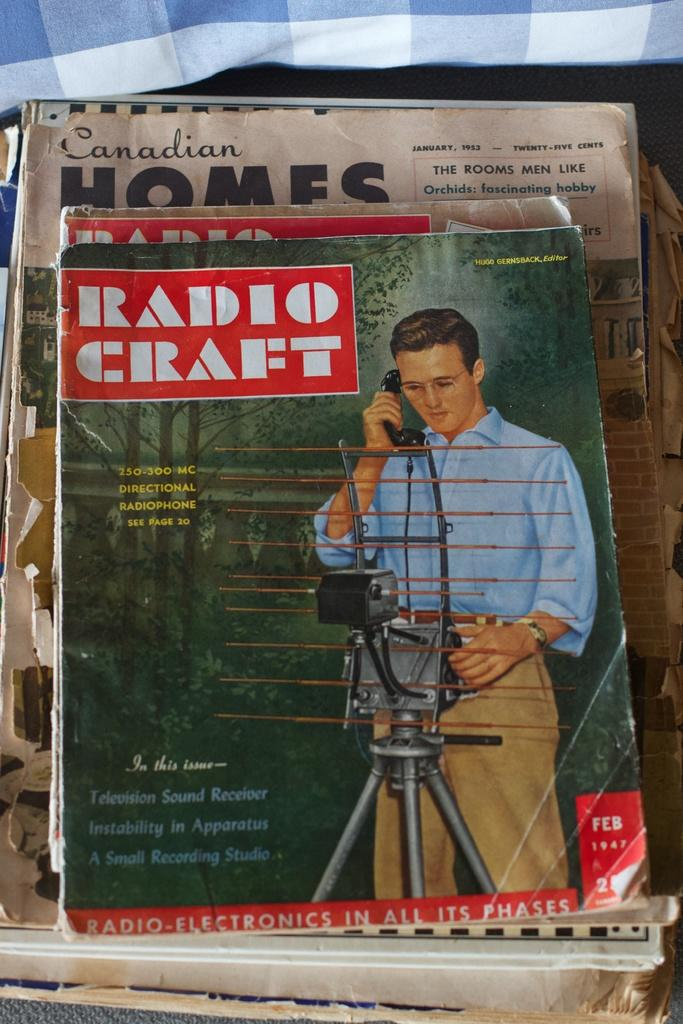<image>
Provide a brief description of the given image. A stack of Radio Craft magazines are piled on top of Canadian Homes magazine. 